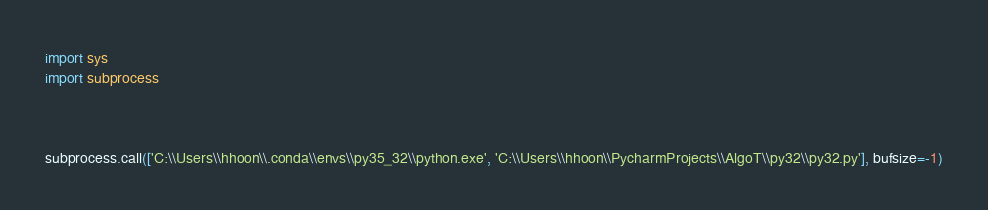<code> <loc_0><loc_0><loc_500><loc_500><_Python_>import sys
import subprocess



subprocess.call(['C:\\Users\\hhoon\\.conda\\envs\\py35_32\\python.exe', 'C:\\Users\\hhoon\\PycharmProjects\\AlgoT\\py32\\py32.py'], bufsize=-1)</code> 